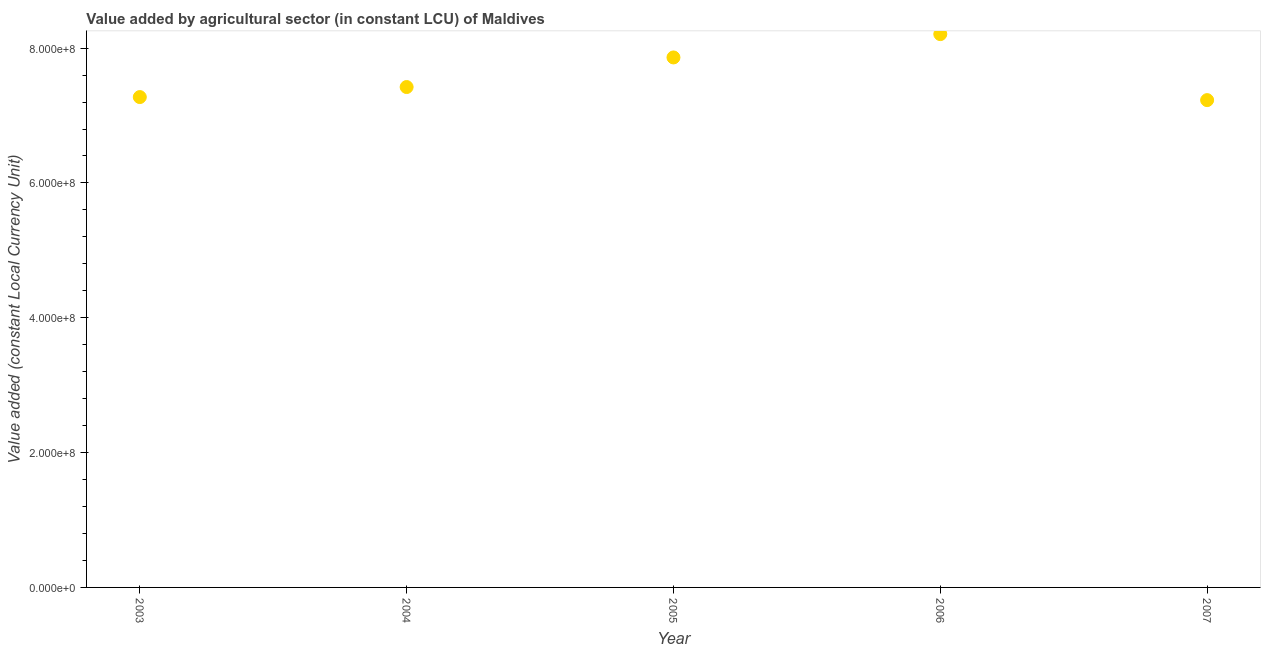What is the value added by agriculture sector in 2005?
Your answer should be very brief. 7.86e+08. Across all years, what is the maximum value added by agriculture sector?
Offer a very short reply. 8.21e+08. Across all years, what is the minimum value added by agriculture sector?
Provide a succinct answer. 7.23e+08. In which year was the value added by agriculture sector maximum?
Your response must be concise. 2006. What is the sum of the value added by agriculture sector?
Your response must be concise. 3.80e+09. What is the difference between the value added by agriculture sector in 2006 and 2007?
Your answer should be very brief. 9.79e+07. What is the average value added by agriculture sector per year?
Provide a succinct answer. 7.60e+08. What is the median value added by agriculture sector?
Offer a very short reply. 7.42e+08. In how many years, is the value added by agriculture sector greater than 240000000 LCU?
Give a very brief answer. 5. What is the ratio of the value added by agriculture sector in 2003 to that in 2007?
Offer a terse response. 1.01. Is the difference between the value added by agriculture sector in 2003 and 2004 greater than the difference between any two years?
Offer a terse response. No. What is the difference between the highest and the second highest value added by agriculture sector?
Make the answer very short. 3.46e+07. What is the difference between the highest and the lowest value added by agriculture sector?
Offer a terse response. 9.79e+07. How many dotlines are there?
Provide a short and direct response. 1. What is the difference between two consecutive major ticks on the Y-axis?
Provide a succinct answer. 2.00e+08. Does the graph contain any zero values?
Ensure brevity in your answer.  No. Does the graph contain grids?
Make the answer very short. No. What is the title of the graph?
Give a very brief answer. Value added by agricultural sector (in constant LCU) of Maldives. What is the label or title of the X-axis?
Ensure brevity in your answer.  Year. What is the label or title of the Y-axis?
Make the answer very short. Value added (constant Local Currency Unit). What is the Value added (constant Local Currency Unit) in 2003?
Give a very brief answer. 7.27e+08. What is the Value added (constant Local Currency Unit) in 2004?
Your answer should be compact. 7.42e+08. What is the Value added (constant Local Currency Unit) in 2005?
Offer a terse response. 7.86e+08. What is the Value added (constant Local Currency Unit) in 2006?
Make the answer very short. 8.21e+08. What is the Value added (constant Local Currency Unit) in 2007?
Your answer should be very brief. 7.23e+08. What is the difference between the Value added (constant Local Currency Unit) in 2003 and 2004?
Keep it short and to the point. -1.49e+07. What is the difference between the Value added (constant Local Currency Unit) in 2003 and 2005?
Give a very brief answer. -5.88e+07. What is the difference between the Value added (constant Local Currency Unit) in 2003 and 2006?
Offer a terse response. -9.34e+07. What is the difference between the Value added (constant Local Currency Unit) in 2003 and 2007?
Offer a very short reply. 4.52e+06. What is the difference between the Value added (constant Local Currency Unit) in 2004 and 2005?
Provide a short and direct response. -4.39e+07. What is the difference between the Value added (constant Local Currency Unit) in 2004 and 2006?
Your answer should be very brief. -7.85e+07. What is the difference between the Value added (constant Local Currency Unit) in 2004 and 2007?
Offer a very short reply. 1.94e+07. What is the difference between the Value added (constant Local Currency Unit) in 2005 and 2006?
Your answer should be compact. -3.46e+07. What is the difference between the Value added (constant Local Currency Unit) in 2005 and 2007?
Offer a terse response. 6.33e+07. What is the difference between the Value added (constant Local Currency Unit) in 2006 and 2007?
Your answer should be compact. 9.79e+07. What is the ratio of the Value added (constant Local Currency Unit) in 2003 to that in 2005?
Keep it short and to the point. 0.93. What is the ratio of the Value added (constant Local Currency Unit) in 2003 to that in 2006?
Offer a terse response. 0.89. What is the ratio of the Value added (constant Local Currency Unit) in 2003 to that in 2007?
Your answer should be very brief. 1.01. What is the ratio of the Value added (constant Local Currency Unit) in 2004 to that in 2005?
Offer a very short reply. 0.94. What is the ratio of the Value added (constant Local Currency Unit) in 2004 to that in 2006?
Offer a very short reply. 0.9. What is the ratio of the Value added (constant Local Currency Unit) in 2004 to that in 2007?
Your answer should be very brief. 1.03. What is the ratio of the Value added (constant Local Currency Unit) in 2005 to that in 2006?
Give a very brief answer. 0.96. What is the ratio of the Value added (constant Local Currency Unit) in 2005 to that in 2007?
Keep it short and to the point. 1.09. What is the ratio of the Value added (constant Local Currency Unit) in 2006 to that in 2007?
Your answer should be compact. 1.14. 